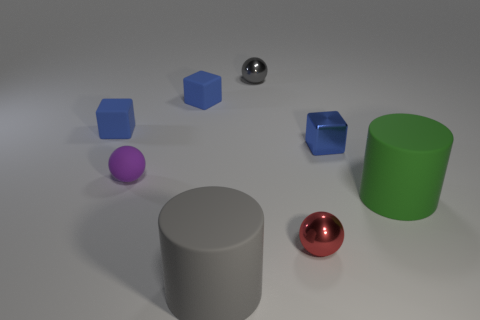What material is the red object that is the same size as the purple ball?
Make the answer very short. Metal. What number of other objects are there of the same material as the large gray cylinder?
Your response must be concise. 4. Are there the same number of green cylinders that are in front of the purple rubber ball and balls on the right side of the tiny blue metallic object?
Offer a very short reply. No. What number of brown things are small things or big things?
Your answer should be compact. 0. Do the rubber ball and the tiny thing that is in front of the large green thing have the same color?
Keep it short and to the point. No. What number of other objects are there of the same color as the matte ball?
Offer a very short reply. 0. Is the number of gray things less than the number of red cylinders?
Provide a succinct answer. No. There is a large matte cylinder that is in front of the large object that is behind the gray cylinder; what number of red metallic balls are left of it?
Your response must be concise. 0. What is the size of the cylinder that is to the left of the red metallic ball?
Make the answer very short. Large. Do the big thing that is on the right side of the blue metallic object and the tiny red metal object have the same shape?
Offer a terse response. No. 